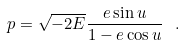<formula> <loc_0><loc_0><loc_500><loc_500>p = \sqrt { - 2 E } \frac { e \sin u } { 1 - e \cos u } \ .</formula> 